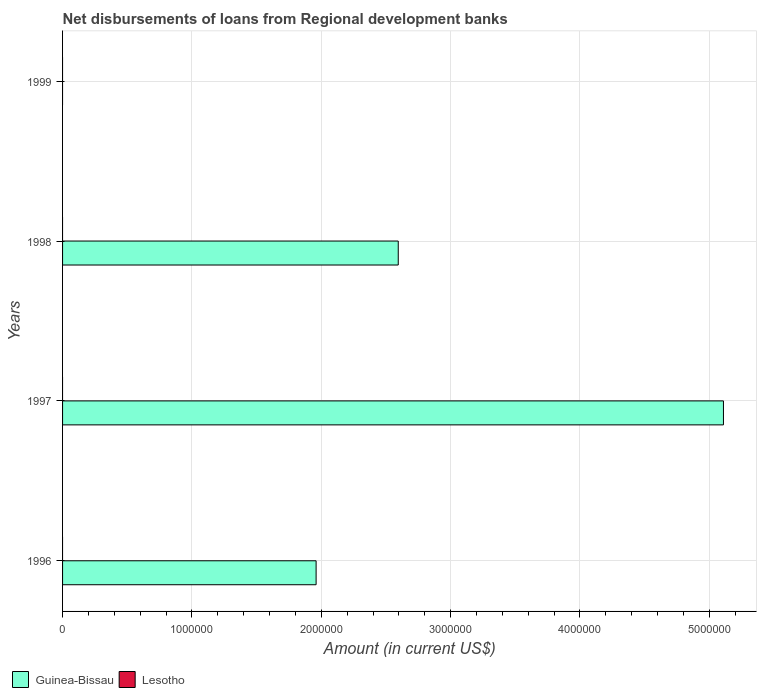How many different coloured bars are there?
Keep it short and to the point. 1. Are the number of bars on each tick of the Y-axis equal?
Offer a very short reply. No. What is the label of the 3rd group of bars from the top?
Your response must be concise. 1997. Across all years, what is the maximum amount of disbursements of loans from regional development banks in Guinea-Bissau?
Provide a short and direct response. 5.11e+06. In which year was the amount of disbursements of loans from regional development banks in Guinea-Bissau maximum?
Offer a terse response. 1997. What is the total amount of disbursements of loans from regional development banks in Guinea-Bissau in the graph?
Provide a succinct answer. 9.66e+06. What is the difference between the amount of disbursements of loans from regional development banks in Guinea-Bissau in 1997 and that in 1998?
Provide a short and direct response. 2.51e+06. What is the difference between the amount of disbursements of loans from regional development banks in Lesotho in 1997 and the amount of disbursements of loans from regional development banks in Guinea-Bissau in 1998?
Offer a terse response. -2.60e+06. In how many years, is the amount of disbursements of loans from regional development banks in Lesotho greater than 200000 US$?
Your answer should be very brief. 0. What is the difference between the highest and the second highest amount of disbursements of loans from regional development banks in Guinea-Bissau?
Ensure brevity in your answer.  2.51e+06. What is the difference between the highest and the lowest amount of disbursements of loans from regional development banks in Guinea-Bissau?
Make the answer very short. 5.11e+06. Are all the bars in the graph horizontal?
Your answer should be very brief. Yes. Are the values on the major ticks of X-axis written in scientific E-notation?
Offer a terse response. No. Does the graph contain any zero values?
Your response must be concise. Yes. Where does the legend appear in the graph?
Ensure brevity in your answer.  Bottom left. How many legend labels are there?
Keep it short and to the point. 2. What is the title of the graph?
Offer a terse response. Net disbursements of loans from Regional development banks. Does "Belarus" appear as one of the legend labels in the graph?
Provide a succinct answer. No. What is the label or title of the X-axis?
Keep it short and to the point. Amount (in current US$). What is the label or title of the Y-axis?
Keep it short and to the point. Years. What is the Amount (in current US$) in Guinea-Bissau in 1996?
Your answer should be compact. 1.96e+06. What is the Amount (in current US$) in Lesotho in 1996?
Make the answer very short. 0. What is the Amount (in current US$) of Guinea-Bissau in 1997?
Give a very brief answer. 5.11e+06. What is the Amount (in current US$) in Lesotho in 1997?
Give a very brief answer. 0. What is the Amount (in current US$) of Guinea-Bissau in 1998?
Keep it short and to the point. 2.60e+06. What is the Amount (in current US$) in Lesotho in 1998?
Offer a terse response. 0. What is the Amount (in current US$) of Guinea-Bissau in 1999?
Your answer should be compact. 0. What is the Amount (in current US$) in Lesotho in 1999?
Your answer should be very brief. 0. Across all years, what is the maximum Amount (in current US$) in Guinea-Bissau?
Provide a short and direct response. 5.11e+06. What is the total Amount (in current US$) in Guinea-Bissau in the graph?
Offer a very short reply. 9.66e+06. What is the total Amount (in current US$) in Lesotho in the graph?
Give a very brief answer. 0. What is the difference between the Amount (in current US$) of Guinea-Bissau in 1996 and that in 1997?
Make the answer very short. -3.15e+06. What is the difference between the Amount (in current US$) in Guinea-Bissau in 1996 and that in 1998?
Offer a very short reply. -6.35e+05. What is the difference between the Amount (in current US$) in Guinea-Bissau in 1997 and that in 1998?
Provide a succinct answer. 2.51e+06. What is the average Amount (in current US$) of Guinea-Bissau per year?
Keep it short and to the point. 2.42e+06. What is the ratio of the Amount (in current US$) in Guinea-Bissau in 1996 to that in 1997?
Offer a very short reply. 0.38. What is the ratio of the Amount (in current US$) of Guinea-Bissau in 1996 to that in 1998?
Make the answer very short. 0.76. What is the ratio of the Amount (in current US$) of Guinea-Bissau in 1997 to that in 1998?
Your response must be concise. 1.97. What is the difference between the highest and the second highest Amount (in current US$) of Guinea-Bissau?
Make the answer very short. 2.51e+06. What is the difference between the highest and the lowest Amount (in current US$) in Guinea-Bissau?
Offer a very short reply. 5.11e+06. 